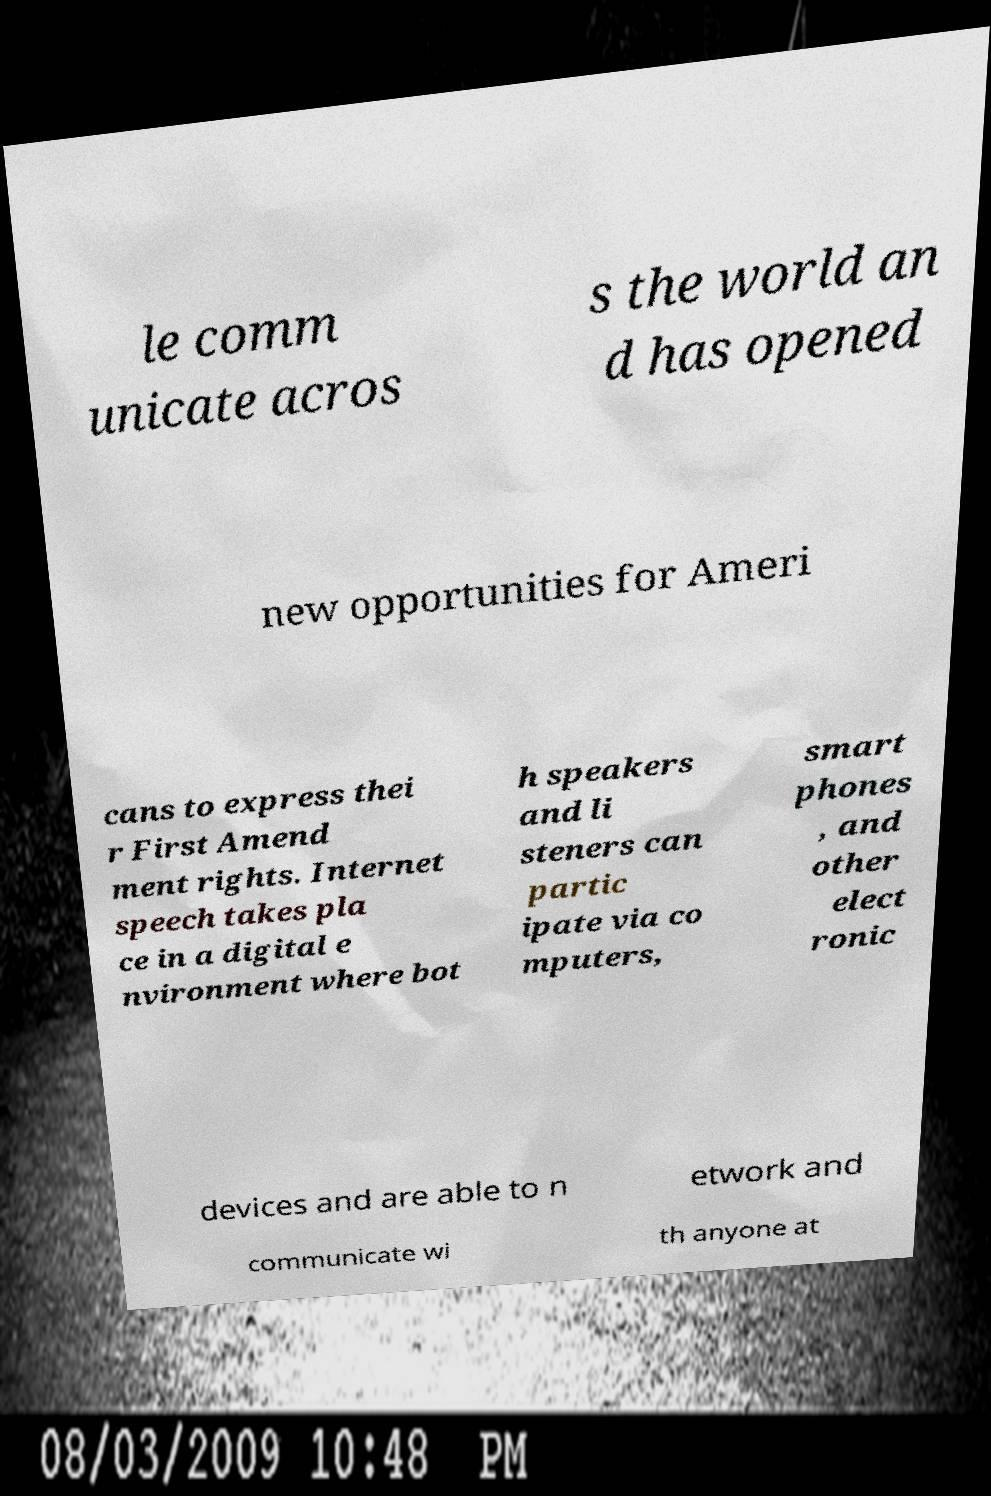Can you accurately transcribe the text from the provided image for me? le comm unicate acros s the world an d has opened new opportunities for Ameri cans to express thei r First Amend ment rights. Internet speech takes pla ce in a digital e nvironment where bot h speakers and li steners can partic ipate via co mputers, smart phones , and other elect ronic devices and are able to n etwork and communicate wi th anyone at 